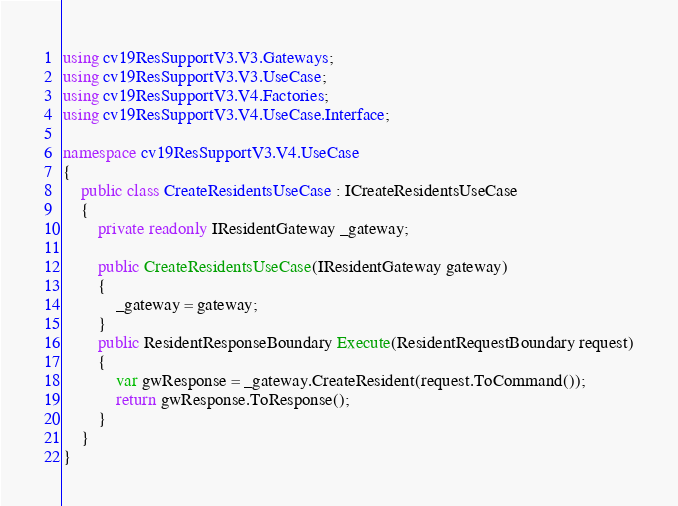Convert code to text. <code><loc_0><loc_0><loc_500><loc_500><_C#_>using cv19ResSupportV3.V3.Gateways;
using cv19ResSupportV3.V3.UseCase;
using cv19ResSupportV3.V4.Factories;
using cv19ResSupportV3.V4.UseCase.Interface;

namespace cv19ResSupportV3.V4.UseCase
{
    public class CreateResidentsUseCase : ICreateResidentsUseCase
    {
        private readonly IResidentGateway _gateway;

        public CreateResidentsUseCase(IResidentGateway gateway)
        {
            _gateway = gateway;
        }
        public ResidentResponseBoundary Execute(ResidentRequestBoundary request)
        {
            var gwResponse = _gateway.CreateResident(request.ToCommand());
            return gwResponse.ToResponse();
        }
    }
}
</code> 